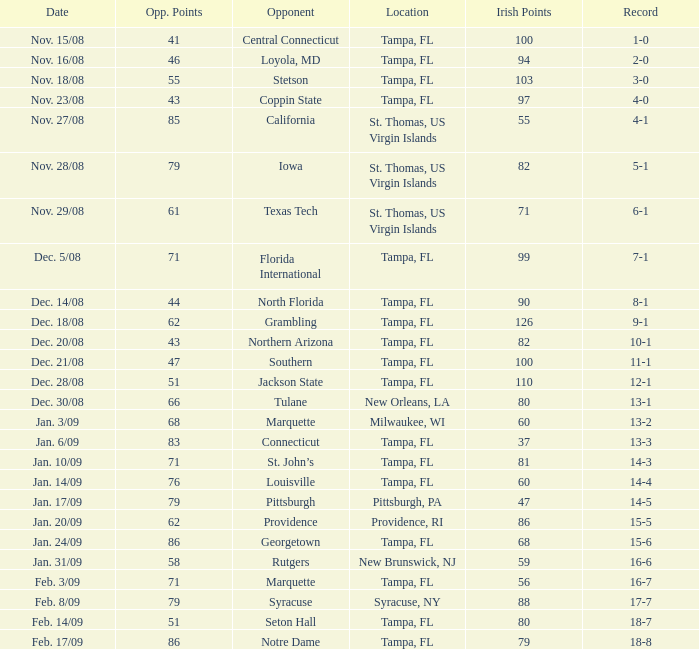What is the record where the locaiton is tampa, fl and the opponent is louisville? 14-4. 